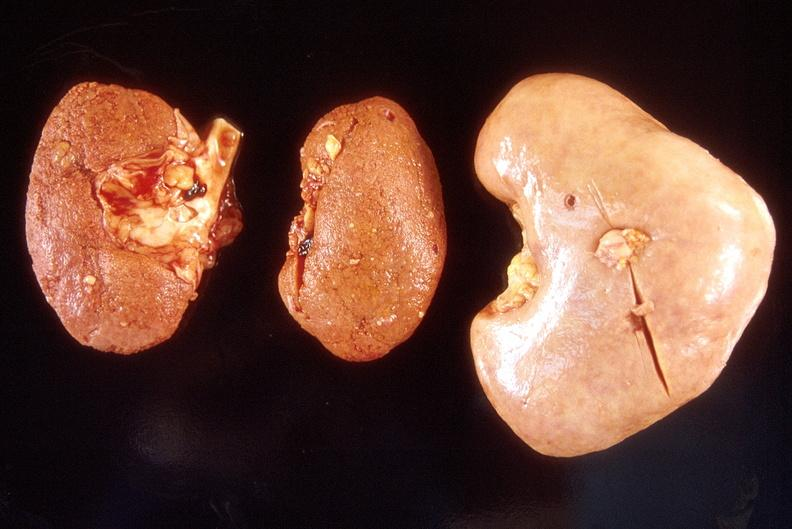what does this image show?
Answer the question using a single word or phrase. Left - native end stage kidneys right - renal allograft abdominal 